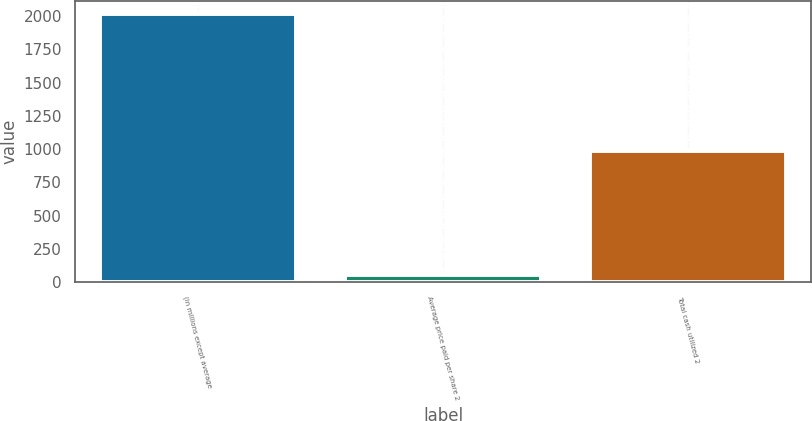Convert chart. <chart><loc_0><loc_0><loc_500><loc_500><bar_chart><fcel>(in millions except average<fcel>Average price paid per share 2<fcel>Total cash utilized 2<nl><fcel>2013<fcel>58.52<fcel>989<nl></chart> 